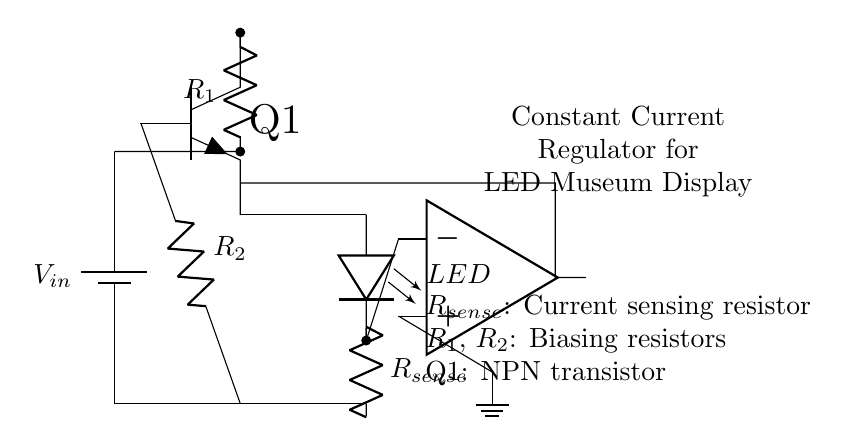What is the input voltage of the circuit? The input voltage is denoted as V_in, which is labeled on the battery symbol in the diagram.
Answer: V_in What is the purpose of the R_sense resistor? R_sense is used to measure the current flowing through the LED; it provides feedback for the current regulation function of the circuit.
Answer: Current sensing How many resistors are present in this circuit? There are three resistors marked: R_1, R_2, and R_sense which are clearly labeled, indicating their use in the circuit.
Answer: Three What type of transistor is used in this circuit? The transistor is specifically labeled as Q1, and it is shown as an NPN transistor, commonly used in current regulation circuits.
Answer: NPN How does the op-amp affect the LED's current? The op-amp compares the voltage across R_sense to a reference voltage, adjusting the base current to Q1 to maintain a constant current through the LED.
Answer: Feedback regulation What role does the battery play in this circuit? The battery provides the necessary input voltage for the entire circuit operation, specifically powering the LED and other components.
Answer: Power supply Which component acts as the load in this circuit? The LED is the load in the circuit, as it consumes current supplied through the constant current regulator setup with R_sense and Q1.
Answer: LED 